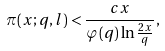<formula> <loc_0><loc_0><loc_500><loc_500>\pi ( x ; q , l ) < { \frac { c x } { \varphi ( q ) \ln { \frac { 2 x } { q } } } } ,</formula> 